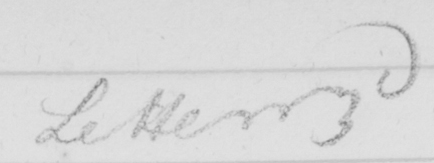What is written in this line of handwriting? Letter 3d 